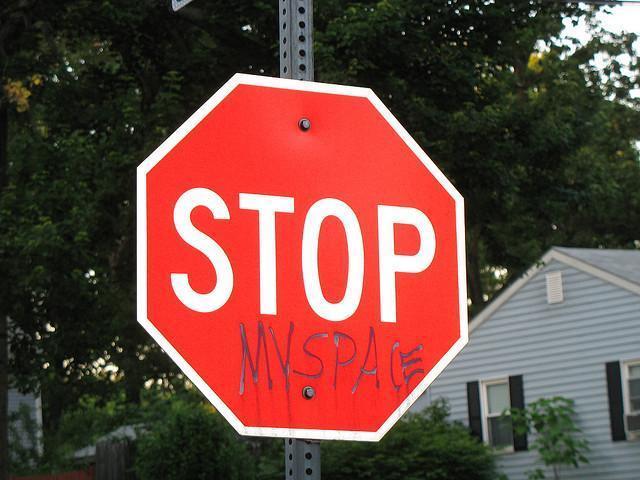How many people are in the photo?
Give a very brief answer. 0. 